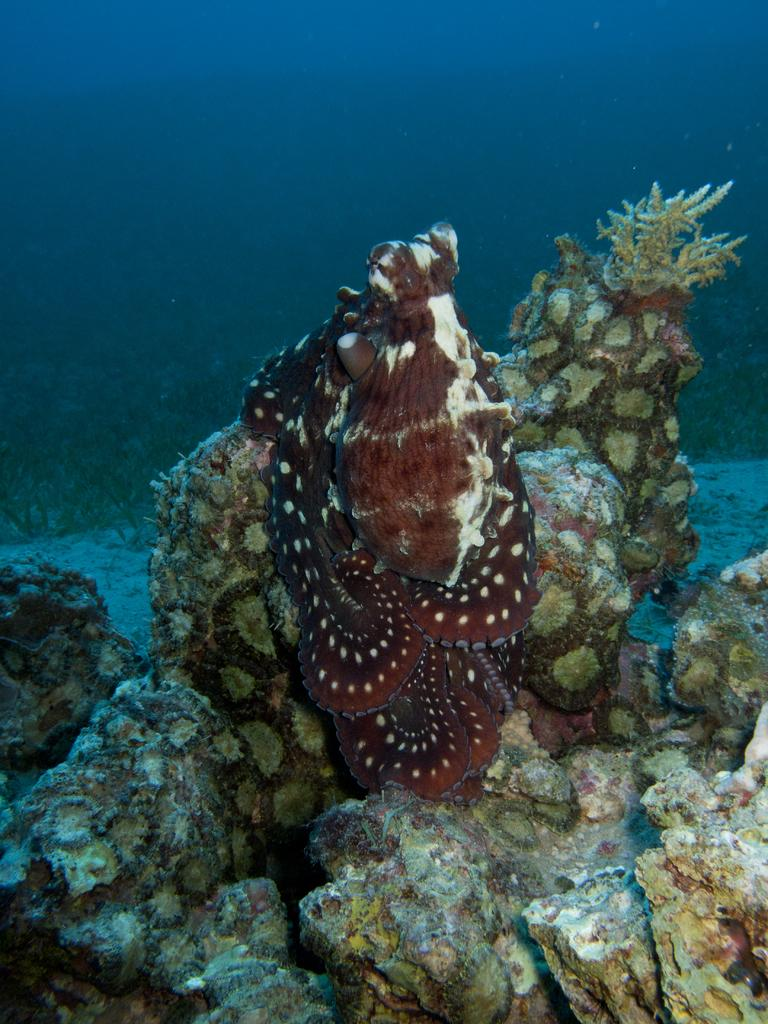Where was the image taken? The image is taken underwater. What type of creature can be seen in the image? There is an aquatic animal in the image. What can be found at the bottom of the image? There are rocks and plants at the bottom of the image. What is the primary element visible in the image? There is water visible in the image. Is the aquatic animal sleeping in the image? There is no indication in the image that the aquatic animal is sleeping. Can you see the aquatic animal's friend in the image? There is no other creature present in the image that could be considered a friend of the aquatic animal. 